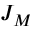Convert formula to latex. <formula><loc_0><loc_0><loc_500><loc_500>J _ { M }</formula> 